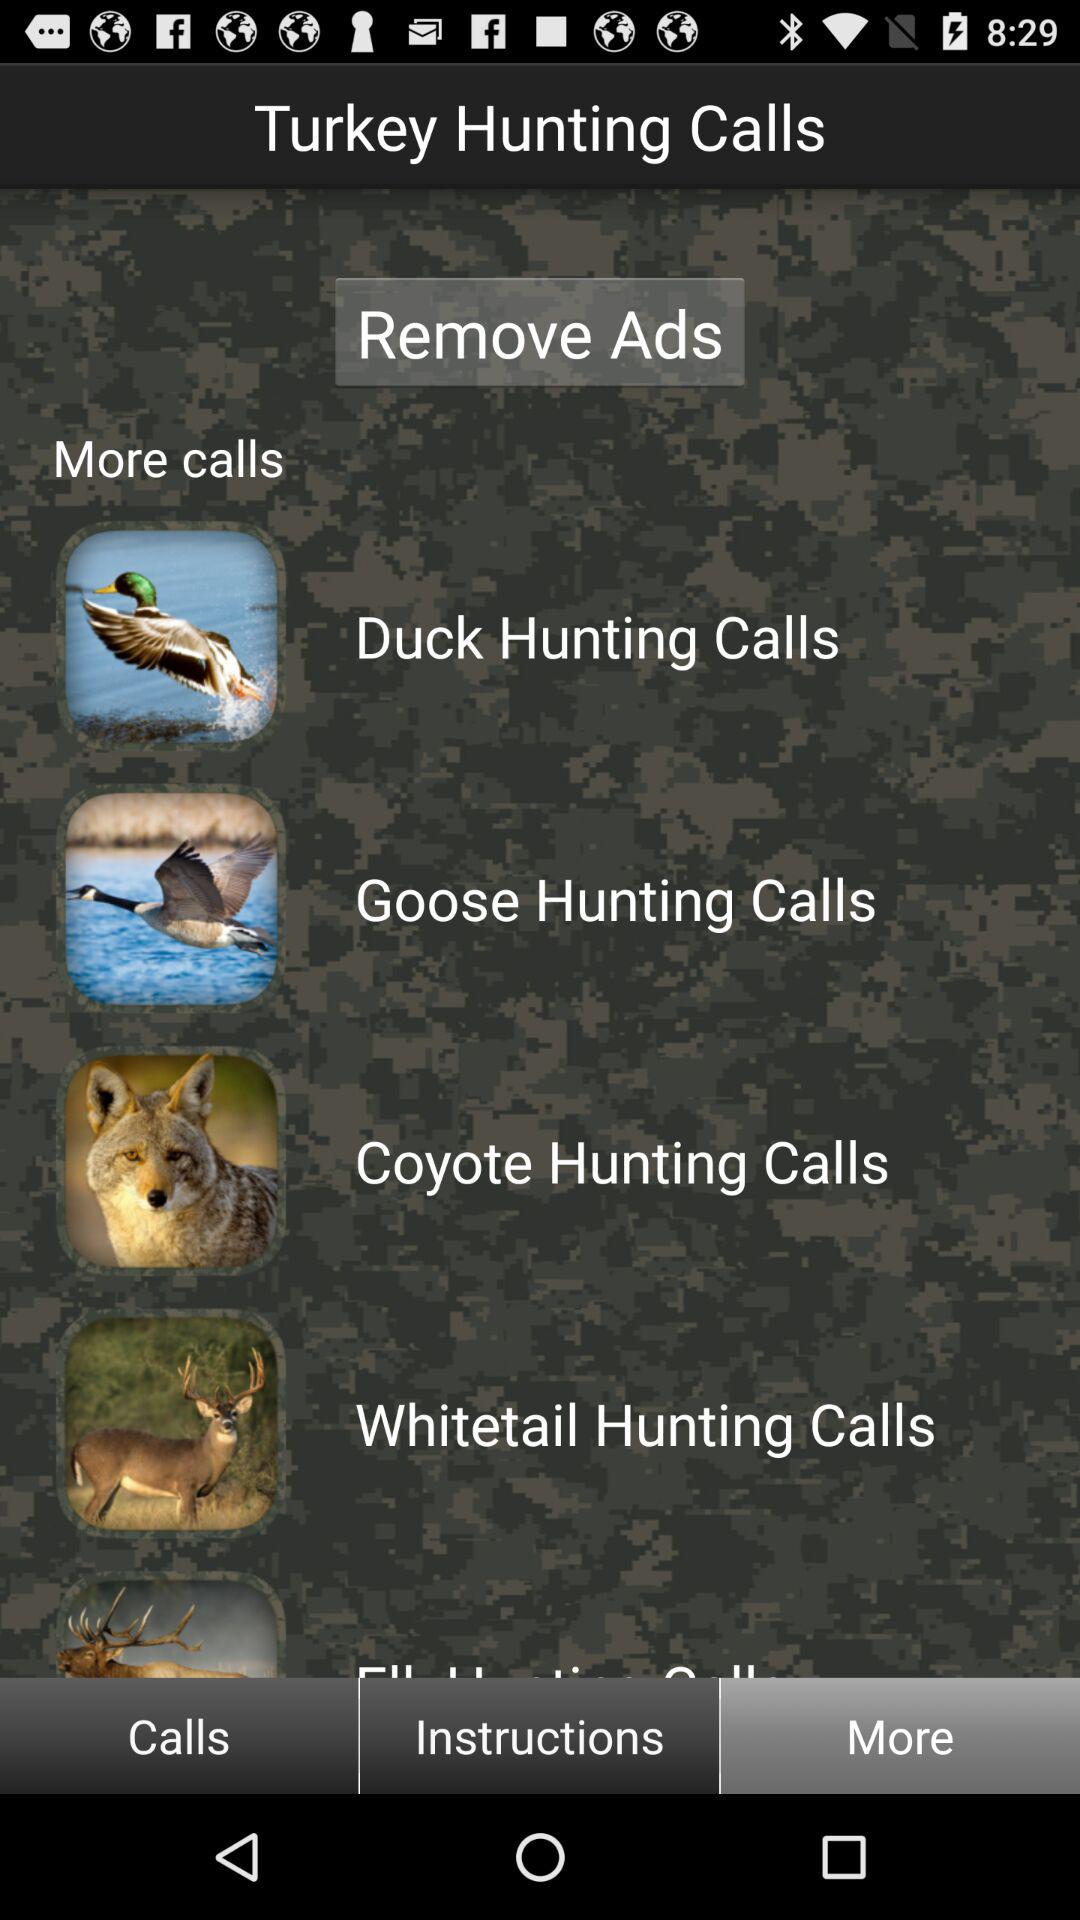What is the application name? The application name is "Turkey Hunting Calls". 